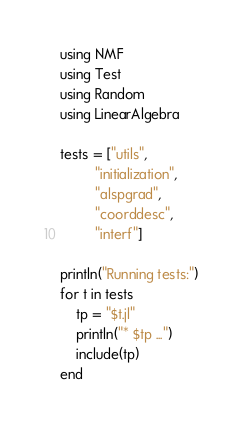Convert code to text. <code><loc_0><loc_0><loc_500><loc_500><_Julia_>using NMF
using Test
using Random
using LinearAlgebra

tests = ["utils",
         "initialization",
         "alspgrad",
         "coorddesc",
         "interf"]

println("Running tests:")
for t in tests
    tp = "$t.jl"
    println("* $tp ...")
    include(tp)
end
</code> 